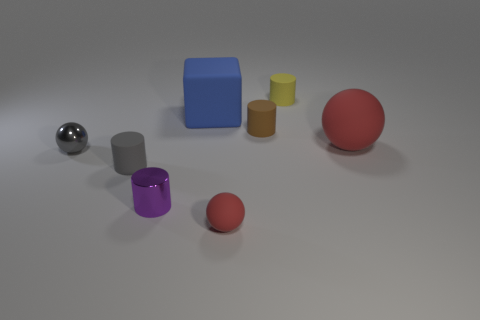Is the number of big blue cylinders less than the number of small red rubber things?
Your answer should be compact. Yes. Is the gray ball made of the same material as the small purple thing?
Keep it short and to the point. Yes. What shape is the matte thing that is the same color as the shiny ball?
Provide a short and direct response. Cylinder. There is a rubber thing that is to the left of the tiny purple object; is it the same color as the big cube?
Provide a short and direct response. No. There is a red thing that is in front of the large matte sphere; how many spheres are behind it?
Provide a short and direct response. 2. What is the color of the matte sphere that is the same size as the cube?
Your answer should be very brief. Red. What material is the sphere on the left side of the small shiny cylinder?
Offer a terse response. Metal. The thing that is behind the gray cylinder and on the left side of the blue matte thing is made of what material?
Make the answer very short. Metal. Does the red rubber sphere in front of the gray cylinder have the same size as the cube?
Offer a terse response. No. The large blue matte object has what shape?
Offer a terse response. Cube. 